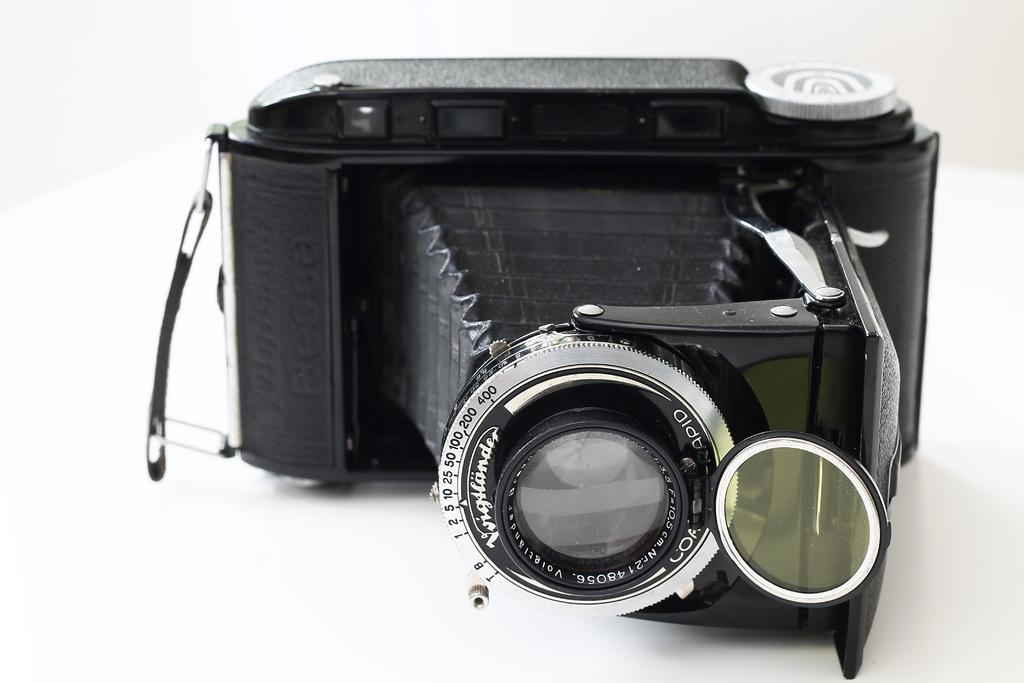What object is the main subject of the image? There is a camera in the image. Where is the camera located in the image? The camera is placed on a table. What type of soup is being prepared on the table next to the camera in the image? There is no soup or any indication of food preparation in the image; it only features a camera placed on a table. 